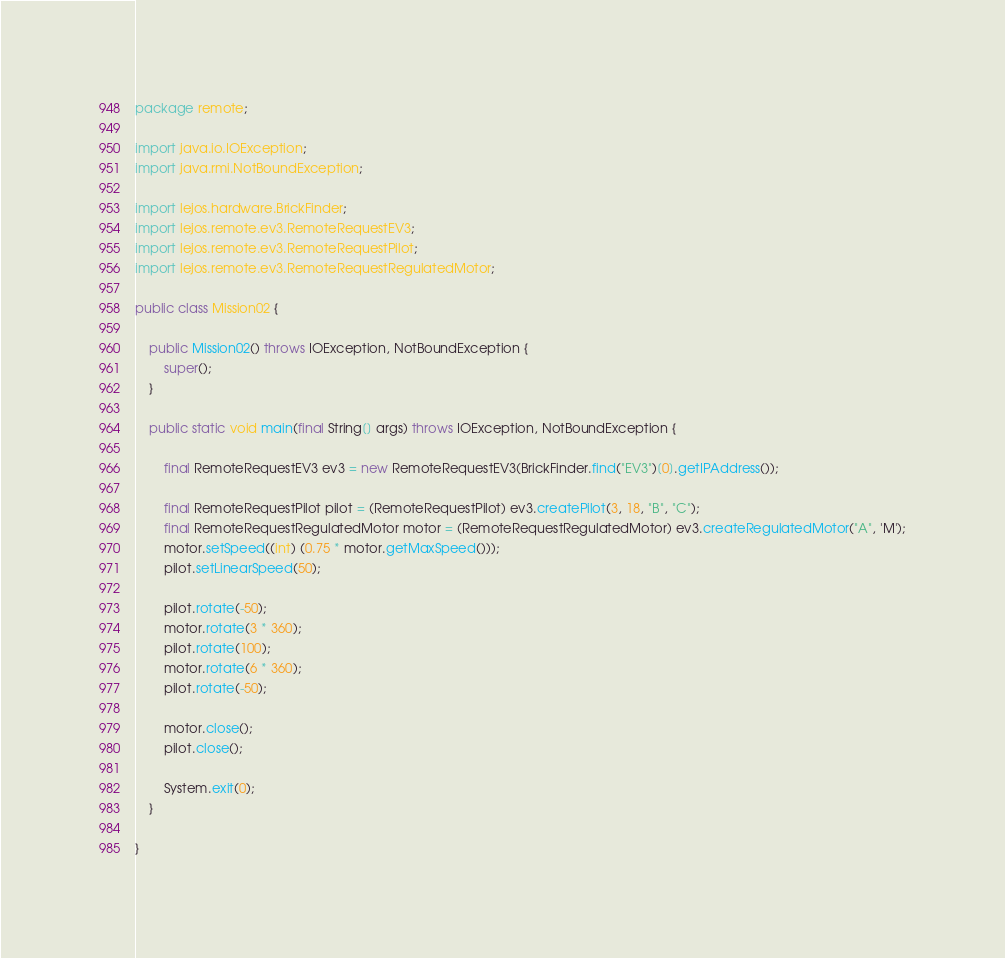Convert code to text. <code><loc_0><loc_0><loc_500><loc_500><_Java_>package remote;

import java.io.IOException;
import java.rmi.NotBoundException;

import lejos.hardware.BrickFinder;
import lejos.remote.ev3.RemoteRequestEV3;
import lejos.remote.ev3.RemoteRequestPilot;
import lejos.remote.ev3.RemoteRequestRegulatedMotor;

public class Mission02 {

    public Mission02() throws IOException, NotBoundException {
        super();
    }

    public static void main(final String[] args) throws IOException, NotBoundException {

        final RemoteRequestEV3 ev3 = new RemoteRequestEV3(BrickFinder.find("EV3")[0].getIPAddress());

        final RemoteRequestPilot pilot = (RemoteRequestPilot) ev3.createPilot(3, 18, "B", "C");
        final RemoteRequestRegulatedMotor motor = (RemoteRequestRegulatedMotor) ev3.createRegulatedMotor("A", 'M');
        motor.setSpeed((int) (0.75 * motor.getMaxSpeed()));
        pilot.setLinearSpeed(50);

        pilot.rotate(-50);
        motor.rotate(3 * 360);
        pilot.rotate(100);
        motor.rotate(6 * 360);
        pilot.rotate(-50);

        motor.close();
        pilot.close();

        System.exit(0);
    }

}</code> 